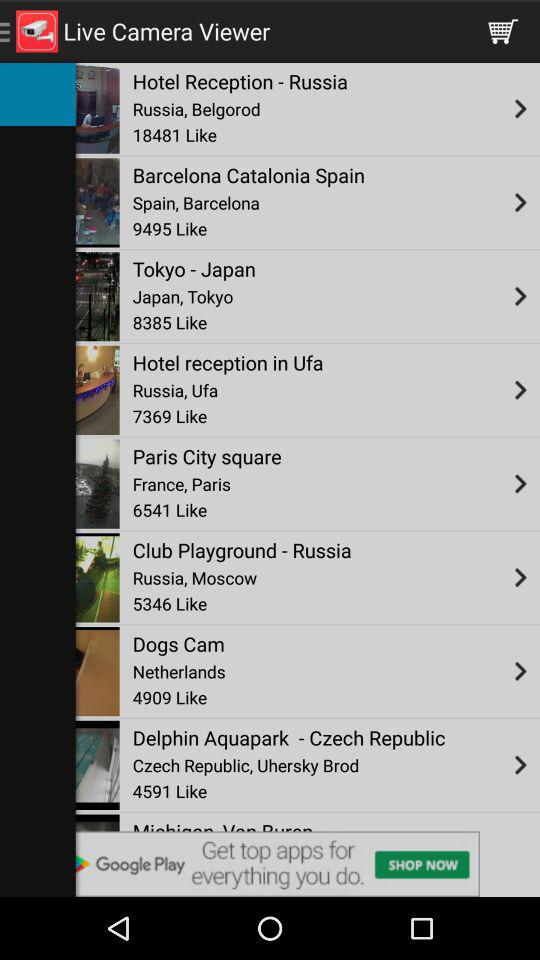How many likes for Paris City Square? There are 6541 likes. 